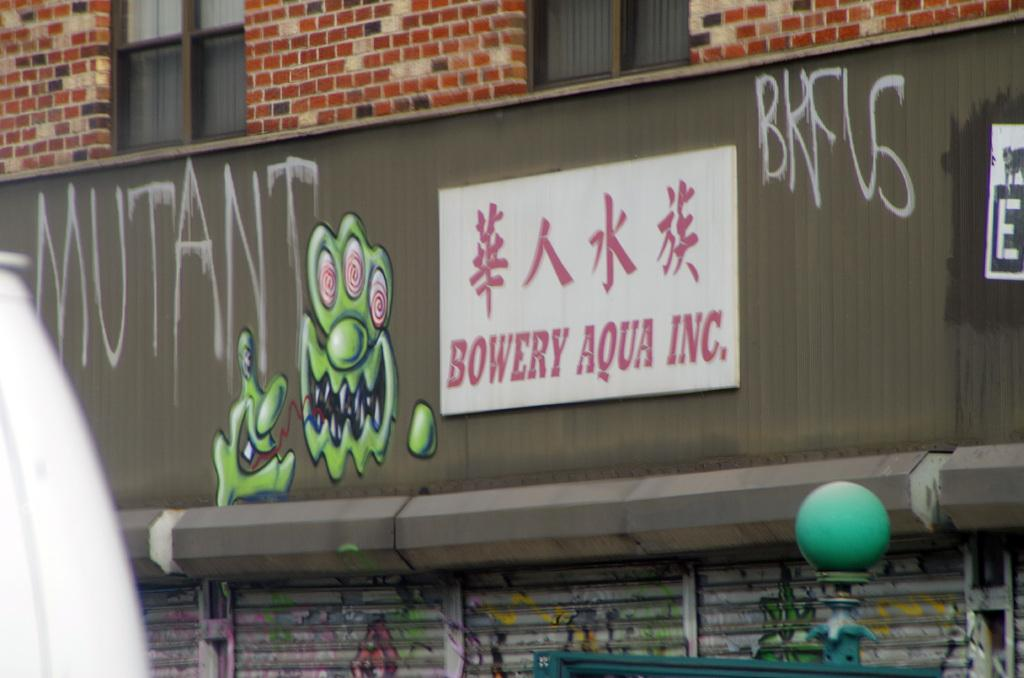What type of structure can be seen in the image? There is a wall in the image. How many windows are visible in the image? There are two windows in the image. What is located in the middle of the image? There is a board in the middle of the image. What is written or displayed on the board? There is text on the board. What is at the bottom of the image? There is a shutter at the bottom of the image. What type of veil is draped over the queen in the image? There is no veil or queen present in the image. What type of lunch is being served in the image? There is no lunch or food being served in the image. 